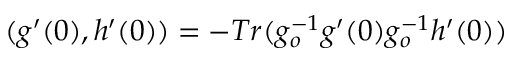Convert formula to latex. <formula><loc_0><loc_0><loc_500><loc_500>( g ^ { \prime } ( 0 ) , h ^ { \prime } ( 0 ) ) = - T r ( g _ { o } ^ { - 1 } g ^ { \prime } ( 0 ) g _ { o } ^ { - 1 } h ^ { \prime } ( 0 ) )</formula> 